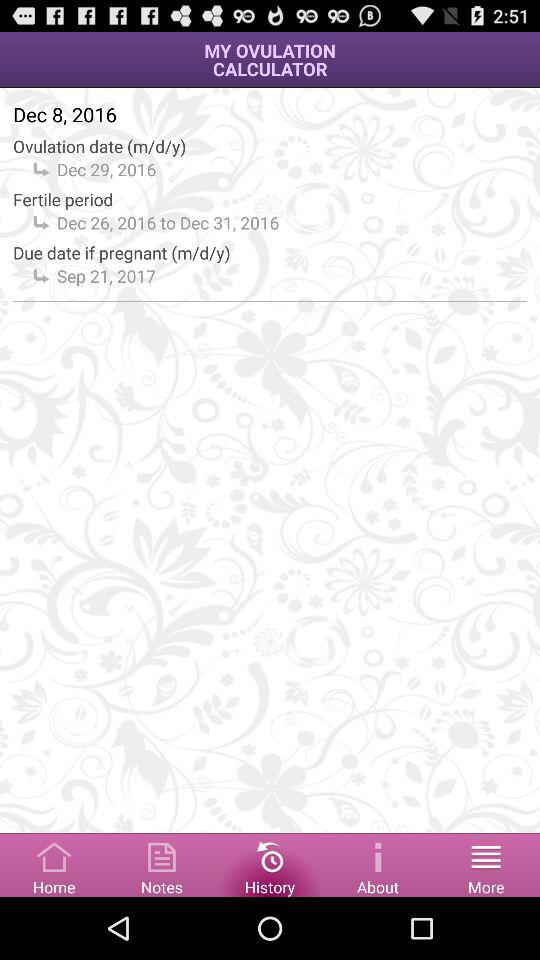What is the duration of the "Fertile period"? The duration is from Dec 26, 2016 to Dec 31, 2016. 